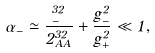<formula> <loc_0><loc_0><loc_500><loc_500>\alpha _ { - } \simeq \frac { \Gamma _ { - } ^ { 3 2 } } { 2 \Gamma _ { A A } ^ { 3 2 } } + \frac { g _ { - } ^ { 2 } } { g _ { + } ^ { 2 } } \ll 1 ,</formula> 